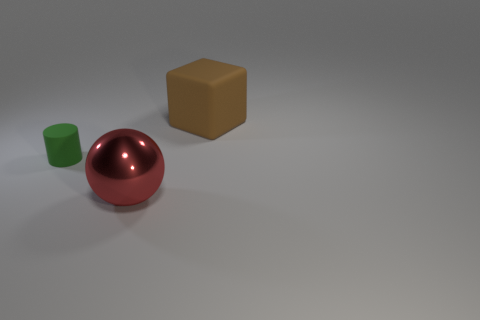What kind of material do the objects appear to be made of? The red ball has a reflective surface, suggesting a polished metal or plastic. The green cylinder looks like matte plastic, and the brown cube could be made of a matte material like wood or plastic, given its solid appearance and lack of reflection. 